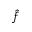<formula> <loc_0><loc_0><loc_500><loc_500>\hat { f }</formula> 